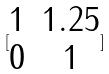<formula> <loc_0><loc_0><loc_500><loc_500>[ \begin{matrix} 1 & 1 . 2 5 \\ 0 & 1 \end{matrix} ]</formula> 